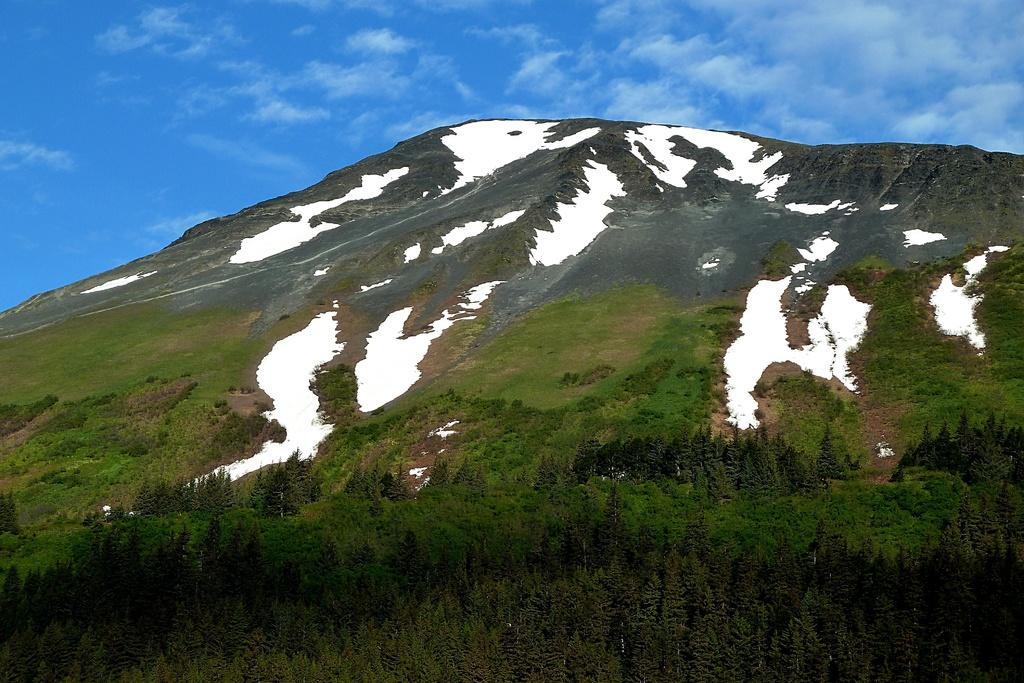What type of landscape is depicted in the image? The image features hills. What types of vegetation can be seen in the image? There are plants, trees, and grass visible in the image. What is the weather like in the image? The presence of snow suggests that it is cold or wintry. What is visible in the sky in the image? The sky is visible in the image, and there are clouds present. Can you see any squirrels playing with toys in the image? There are no squirrels or toys present in the image. What type of home is visible in the image? There is no home visible in the image; it features a natural landscape with hills, plants, trees, grass, snow, and a sky with clouds. 